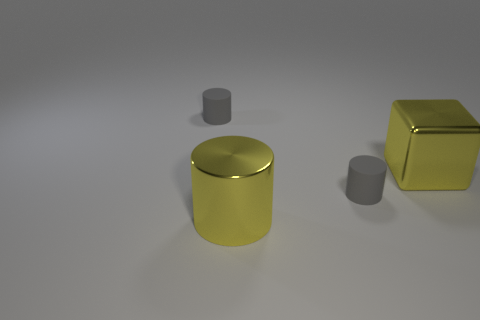How many gray cylinders must be subtracted to get 1 gray cylinders? 1 Add 4 purple metallic balls. How many objects exist? 8 Subtract all cylinders. How many objects are left? 1 Subtract all small cylinders. Subtract all small gray cylinders. How many objects are left? 0 Add 3 large yellow shiny blocks. How many large yellow shiny blocks are left? 4 Add 3 big cylinders. How many big cylinders exist? 4 Subtract 2 gray cylinders. How many objects are left? 2 